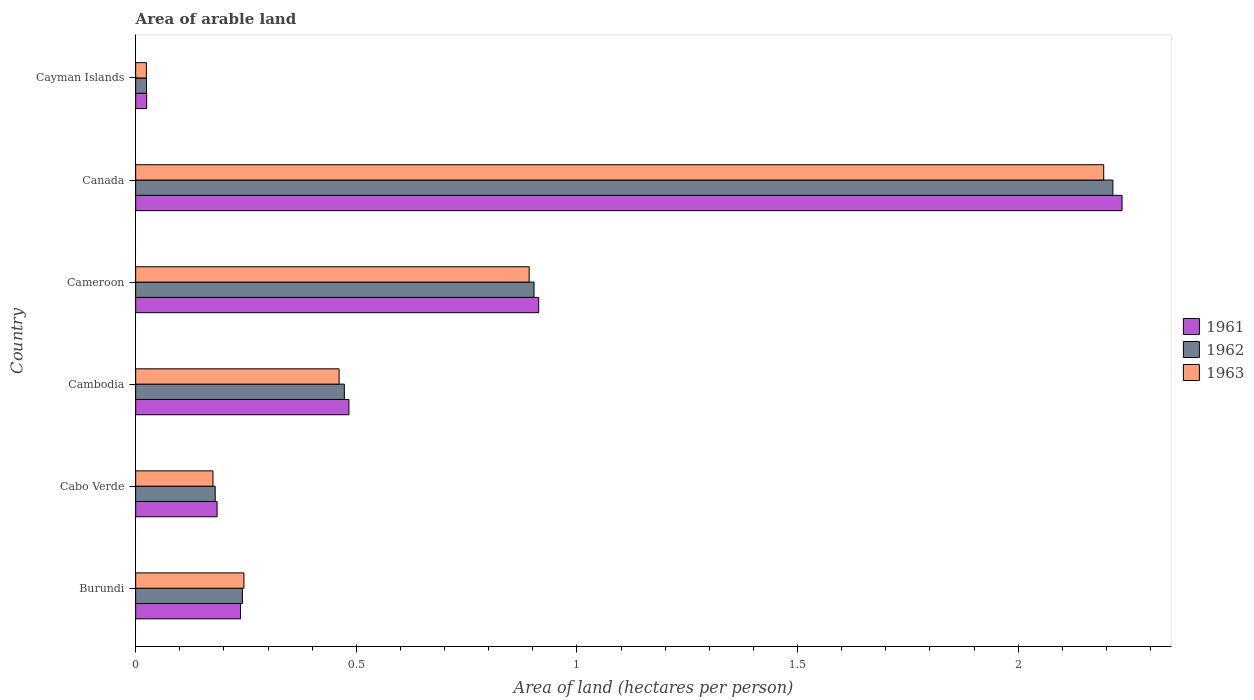How many groups of bars are there?
Your answer should be very brief. 6. Are the number of bars on each tick of the Y-axis equal?
Your answer should be compact. Yes. What is the total arable land in 1961 in Canada?
Ensure brevity in your answer.  2.24. Across all countries, what is the maximum total arable land in 1961?
Provide a short and direct response. 2.24. Across all countries, what is the minimum total arable land in 1962?
Your answer should be very brief. 0.02. In which country was the total arable land in 1963 maximum?
Ensure brevity in your answer.  Canada. In which country was the total arable land in 1963 minimum?
Give a very brief answer. Cayman Islands. What is the total total arable land in 1963 in the graph?
Your answer should be compact. 3.99. What is the difference between the total arable land in 1962 in Cameroon and that in Cayman Islands?
Offer a very short reply. 0.88. What is the difference between the total arable land in 1962 in Burundi and the total arable land in 1961 in Cabo Verde?
Your answer should be compact. 0.06. What is the average total arable land in 1962 per country?
Ensure brevity in your answer.  0.67. What is the difference between the total arable land in 1961 and total arable land in 1963 in Cambodia?
Your response must be concise. 0.02. In how many countries, is the total arable land in 1961 greater than 0.1 hectares per person?
Your answer should be very brief. 5. What is the ratio of the total arable land in 1962 in Cabo Verde to that in Canada?
Your answer should be very brief. 0.08. What is the difference between the highest and the second highest total arable land in 1962?
Provide a short and direct response. 1.31. What is the difference between the highest and the lowest total arable land in 1963?
Your response must be concise. 2.17. Is the sum of the total arable land in 1961 in Cabo Verde and Cambodia greater than the maximum total arable land in 1963 across all countries?
Provide a short and direct response. No. Is it the case that in every country, the sum of the total arable land in 1961 and total arable land in 1962 is greater than the total arable land in 1963?
Your response must be concise. Yes. Are all the bars in the graph horizontal?
Provide a succinct answer. Yes. Are the values on the major ticks of X-axis written in scientific E-notation?
Provide a short and direct response. No. Does the graph contain any zero values?
Provide a succinct answer. No. Does the graph contain grids?
Ensure brevity in your answer.  No. How many legend labels are there?
Your response must be concise. 3. What is the title of the graph?
Make the answer very short. Area of arable land. What is the label or title of the X-axis?
Offer a terse response. Area of land (hectares per person). What is the label or title of the Y-axis?
Provide a succinct answer. Country. What is the Area of land (hectares per person) in 1961 in Burundi?
Your response must be concise. 0.24. What is the Area of land (hectares per person) of 1962 in Burundi?
Keep it short and to the point. 0.24. What is the Area of land (hectares per person) in 1963 in Burundi?
Provide a short and direct response. 0.25. What is the Area of land (hectares per person) of 1961 in Cabo Verde?
Ensure brevity in your answer.  0.18. What is the Area of land (hectares per person) in 1962 in Cabo Verde?
Offer a terse response. 0.18. What is the Area of land (hectares per person) in 1963 in Cabo Verde?
Provide a short and direct response. 0.18. What is the Area of land (hectares per person) in 1961 in Cambodia?
Keep it short and to the point. 0.48. What is the Area of land (hectares per person) of 1962 in Cambodia?
Provide a short and direct response. 0.47. What is the Area of land (hectares per person) in 1963 in Cambodia?
Keep it short and to the point. 0.46. What is the Area of land (hectares per person) of 1961 in Cameroon?
Make the answer very short. 0.91. What is the Area of land (hectares per person) in 1962 in Cameroon?
Make the answer very short. 0.9. What is the Area of land (hectares per person) of 1963 in Cameroon?
Your answer should be compact. 0.89. What is the Area of land (hectares per person) of 1961 in Canada?
Ensure brevity in your answer.  2.24. What is the Area of land (hectares per person) of 1962 in Canada?
Provide a succinct answer. 2.21. What is the Area of land (hectares per person) in 1963 in Canada?
Offer a terse response. 2.19. What is the Area of land (hectares per person) in 1961 in Cayman Islands?
Provide a short and direct response. 0.02. What is the Area of land (hectares per person) of 1962 in Cayman Islands?
Offer a terse response. 0.02. What is the Area of land (hectares per person) of 1963 in Cayman Islands?
Provide a succinct answer. 0.02. Across all countries, what is the maximum Area of land (hectares per person) in 1961?
Your answer should be compact. 2.24. Across all countries, what is the maximum Area of land (hectares per person) of 1962?
Offer a very short reply. 2.21. Across all countries, what is the maximum Area of land (hectares per person) of 1963?
Give a very brief answer. 2.19. Across all countries, what is the minimum Area of land (hectares per person) of 1961?
Offer a very short reply. 0.02. Across all countries, what is the minimum Area of land (hectares per person) of 1962?
Your answer should be compact. 0.02. Across all countries, what is the minimum Area of land (hectares per person) in 1963?
Keep it short and to the point. 0.02. What is the total Area of land (hectares per person) of 1961 in the graph?
Your answer should be very brief. 4.08. What is the total Area of land (hectares per person) in 1962 in the graph?
Ensure brevity in your answer.  4.04. What is the total Area of land (hectares per person) in 1963 in the graph?
Your answer should be compact. 3.99. What is the difference between the Area of land (hectares per person) in 1961 in Burundi and that in Cabo Verde?
Your answer should be compact. 0.05. What is the difference between the Area of land (hectares per person) in 1962 in Burundi and that in Cabo Verde?
Keep it short and to the point. 0.06. What is the difference between the Area of land (hectares per person) in 1963 in Burundi and that in Cabo Verde?
Offer a terse response. 0.07. What is the difference between the Area of land (hectares per person) of 1961 in Burundi and that in Cambodia?
Provide a succinct answer. -0.25. What is the difference between the Area of land (hectares per person) of 1962 in Burundi and that in Cambodia?
Keep it short and to the point. -0.23. What is the difference between the Area of land (hectares per person) in 1963 in Burundi and that in Cambodia?
Ensure brevity in your answer.  -0.22. What is the difference between the Area of land (hectares per person) in 1961 in Burundi and that in Cameroon?
Ensure brevity in your answer.  -0.68. What is the difference between the Area of land (hectares per person) of 1962 in Burundi and that in Cameroon?
Offer a terse response. -0.66. What is the difference between the Area of land (hectares per person) of 1963 in Burundi and that in Cameroon?
Keep it short and to the point. -0.65. What is the difference between the Area of land (hectares per person) in 1961 in Burundi and that in Canada?
Ensure brevity in your answer.  -2. What is the difference between the Area of land (hectares per person) of 1962 in Burundi and that in Canada?
Your response must be concise. -1.97. What is the difference between the Area of land (hectares per person) in 1963 in Burundi and that in Canada?
Your response must be concise. -1.95. What is the difference between the Area of land (hectares per person) of 1961 in Burundi and that in Cayman Islands?
Provide a short and direct response. 0.21. What is the difference between the Area of land (hectares per person) of 1962 in Burundi and that in Cayman Islands?
Ensure brevity in your answer.  0.22. What is the difference between the Area of land (hectares per person) of 1963 in Burundi and that in Cayman Islands?
Provide a short and direct response. 0.22. What is the difference between the Area of land (hectares per person) in 1961 in Cabo Verde and that in Cambodia?
Keep it short and to the point. -0.3. What is the difference between the Area of land (hectares per person) in 1962 in Cabo Verde and that in Cambodia?
Ensure brevity in your answer.  -0.29. What is the difference between the Area of land (hectares per person) in 1963 in Cabo Verde and that in Cambodia?
Make the answer very short. -0.29. What is the difference between the Area of land (hectares per person) of 1961 in Cabo Verde and that in Cameroon?
Offer a very short reply. -0.73. What is the difference between the Area of land (hectares per person) in 1962 in Cabo Verde and that in Cameroon?
Offer a very short reply. -0.72. What is the difference between the Area of land (hectares per person) in 1963 in Cabo Verde and that in Cameroon?
Offer a terse response. -0.72. What is the difference between the Area of land (hectares per person) of 1961 in Cabo Verde and that in Canada?
Offer a terse response. -2.05. What is the difference between the Area of land (hectares per person) in 1962 in Cabo Verde and that in Canada?
Keep it short and to the point. -2.03. What is the difference between the Area of land (hectares per person) in 1963 in Cabo Verde and that in Canada?
Your answer should be very brief. -2.02. What is the difference between the Area of land (hectares per person) in 1961 in Cabo Verde and that in Cayman Islands?
Your answer should be very brief. 0.16. What is the difference between the Area of land (hectares per person) in 1962 in Cabo Verde and that in Cayman Islands?
Your response must be concise. 0.16. What is the difference between the Area of land (hectares per person) of 1963 in Cabo Verde and that in Cayman Islands?
Ensure brevity in your answer.  0.15. What is the difference between the Area of land (hectares per person) of 1961 in Cambodia and that in Cameroon?
Offer a very short reply. -0.43. What is the difference between the Area of land (hectares per person) in 1962 in Cambodia and that in Cameroon?
Give a very brief answer. -0.43. What is the difference between the Area of land (hectares per person) of 1963 in Cambodia and that in Cameroon?
Your answer should be compact. -0.43. What is the difference between the Area of land (hectares per person) of 1961 in Cambodia and that in Canada?
Ensure brevity in your answer.  -1.75. What is the difference between the Area of land (hectares per person) of 1962 in Cambodia and that in Canada?
Give a very brief answer. -1.74. What is the difference between the Area of land (hectares per person) in 1963 in Cambodia and that in Canada?
Offer a very short reply. -1.73. What is the difference between the Area of land (hectares per person) in 1961 in Cambodia and that in Cayman Islands?
Your response must be concise. 0.46. What is the difference between the Area of land (hectares per person) of 1962 in Cambodia and that in Cayman Islands?
Make the answer very short. 0.45. What is the difference between the Area of land (hectares per person) of 1963 in Cambodia and that in Cayman Islands?
Offer a very short reply. 0.44. What is the difference between the Area of land (hectares per person) in 1961 in Cameroon and that in Canada?
Provide a short and direct response. -1.32. What is the difference between the Area of land (hectares per person) of 1962 in Cameroon and that in Canada?
Your answer should be compact. -1.31. What is the difference between the Area of land (hectares per person) of 1963 in Cameroon and that in Canada?
Ensure brevity in your answer.  -1.3. What is the difference between the Area of land (hectares per person) in 1961 in Cameroon and that in Cayman Islands?
Your answer should be compact. 0.89. What is the difference between the Area of land (hectares per person) in 1962 in Cameroon and that in Cayman Islands?
Your response must be concise. 0.88. What is the difference between the Area of land (hectares per person) in 1963 in Cameroon and that in Cayman Islands?
Provide a succinct answer. 0.87. What is the difference between the Area of land (hectares per person) in 1961 in Canada and that in Cayman Islands?
Your response must be concise. 2.21. What is the difference between the Area of land (hectares per person) in 1962 in Canada and that in Cayman Islands?
Offer a terse response. 2.19. What is the difference between the Area of land (hectares per person) of 1963 in Canada and that in Cayman Islands?
Provide a succinct answer. 2.17. What is the difference between the Area of land (hectares per person) of 1961 in Burundi and the Area of land (hectares per person) of 1962 in Cabo Verde?
Give a very brief answer. 0.06. What is the difference between the Area of land (hectares per person) in 1961 in Burundi and the Area of land (hectares per person) in 1963 in Cabo Verde?
Your response must be concise. 0.06. What is the difference between the Area of land (hectares per person) of 1962 in Burundi and the Area of land (hectares per person) of 1963 in Cabo Verde?
Offer a very short reply. 0.07. What is the difference between the Area of land (hectares per person) in 1961 in Burundi and the Area of land (hectares per person) in 1962 in Cambodia?
Offer a terse response. -0.24. What is the difference between the Area of land (hectares per person) in 1961 in Burundi and the Area of land (hectares per person) in 1963 in Cambodia?
Your answer should be compact. -0.22. What is the difference between the Area of land (hectares per person) of 1962 in Burundi and the Area of land (hectares per person) of 1963 in Cambodia?
Offer a very short reply. -0.22. What is the difference between the Area of land (hectares per person) in 1961 in Burundi and the Area of land (hectares per person) in 1962 in Cameroon?
Offer a terse response. -0.67. What is the difference between the Area of land (hectares per person) in 1961 in Burundi and the Area of land (hectares per person) in 1963 in Cameroon?
Offer a terse response. -0.65. What is the difference between the Area of land (hectares per person) in 1962 in Burundi and the Area of land (hectares per person) in 1963 in Cameroon?
Make the answer very short. -0.65. What is the difference between the Area of land (hectares per person) of 1961 in Burundi and the Area of land (hectares per person) of 1962 in Canada?
Keep it short and to the point. -1.98. What is the difference between the Area of land (hectares per person) in 1961 in Burundi and the Area of land (hectares per person) in 1963 in Canada?
Keep it short and to the point. -1.96. What is the difference between the Area of land (hectares per person) of 1962 in Burundi and the Area of land (hectares per person) of 1963 in Canada?
Make the answer very short. -1.95. What is the difference between the Area of land (hectares per person) of 1961 in Burundi and the Area of land (hectares per person) of 1962 in Cayman Islands?
Offer a terse response. 0.21. What is the difference between the Area of land (hectares per person) in 1961 in Burundi and the Area of land (hectares per person) in 1963 in Cayman Islands?
Give a very brief answer. 0.21. What is the difference between the Area of land (hectares per person) of 1962 in Burundi and the Area of land (hectares per person) of 1963 in Cayman Islands?
Provide a succinct answer. 0.22. What is the difference between the Area of land (hectares per person) in 1961 in Cabo Verde and the Area of land (hectares per person) in 1962 in Cambodia?
Your answer should be very brief. -0.29. What is the difference between the Area of land (hectares per person) of 1961 in Cabo Verde and the Area of land (hectares per person) of 1963 in Cambodia?
Provide a succinct answer. -0.28. What is the difference between the Area of land (hectares per person) of 1962 in Cabo Verde and the Area of land (hectares per person) of 1963 in Cambodia?
Give a very brief answer. -0.28. What is the difference between the Area of land (hectares per person) of 1961 in Cabo Verde and the Area of land (hectares per person) of 1962 in Cameroon?
Keep it short and to the point. -0.72. What is the difference between the Area of land (hectares per person) in 1961 in Cabo Verde and the Area of land (hectares per person) in 1963 in Cameroon?
Your response must be concise. -0.71. What is the difference between the Area of land (hectares per person) in 1962 in Cabo Verde and the Area of land (hectares per person) in 1963 in Cameroon?
Your response must be concise. -0.71. What is the difference between the Area of land (hectares per person) of 1961 in Cabo Verde and the Area of land (hectares per person) of 1962 in Canada?
Offer a terse response. -2.03. What is the difference between the Area of land (hectares per person) in 1961 in Cabo Verde and the Area of land (hectares per person) in 1963 in Canada?
Offer a very short reply. -2.01. What is the difference between the Area of land (hectares per person) in 1962 in Cabo Verde and the Area of land (hectares per person) in 1963 in Canada?
Offer a terse response. -2.01. What is the difference between the Area of land (hectares per person) of 1961 in Cabo Verde and the Area of land (hectares per person) of 1962 in Cayman Islands?
Make the answer very short. 0.16. What is the difference between the Area of land (hectares per person) in 1961 in Cabo Verde and the Area of land (hectares per person) in 1963 in Cayman Islands?
Provide a succinct answer. 0.16. What is the difference between the Area of land (hectares per person) of 1962 in Cabo Verde and the Area of land (hectares per person) of 1963 in Cayman Islands?
Your answer should be very brief. 0.16. What is the difference between the Area of land (hectares per person) in 1961 in Cambodia and the Area of land (hectares per person) in 1962 in Cameroon?
Offer a terse response. -0.42. What is the difference between the Area of land (hectares per person) in 1961 in Cambodia and the Area of land (hectares per person) in 1963 in Cameroon?
Keep it short and to the point. -0.41. What is the difference between the Area of land (hectares per person) of 1962 in Cambodia and the Area of land (hectares per person) of 1963 in Cameroon?
Your answer should be compact. -0.42. What is the difference between the Area of land (hectares per person) of 1961 in Cambodia and the Area of land (hectares per person) of 1962 in Canada?
Keep it short and to the point. -1.73. What is the difference between the Area of land (hectares per person) of 1961 in Cambodia and the Area of land (hectares per person) of 1963 in Canada?
Offer a terse response. -1.71. What is the difference between the Area of land (hectares per person) in 1962 in Cambodia and the Area of land (hectares per person) in 1963 in Canada?
Keep it short and to the point. -1.72. What is the difference between the Area of land (hectares per person) in 1961 in Cambodia and the Area of land (hectares per person) in 1962 in Cayman Islands?
Give a very brief answer. 0.46. What is the difference between the Area of land (hectares per person) of 1961 in Cambodia and the Area of land (hectares per person) of 1963 in Cayman Islands?
Offer a very short reply. 0.46. What is the difference between the Area of land (hectares per person) of 1962 in Cambodia and the Area of land (hectares per person) of 1963 in Cayman Islands?
Your response must be concise. 0.45. What is the difference between the Area of land (hectares per person) in 1961 in Cameroon and the Area of land (hectares per person) in 1962 in Canada?
Ensure brevity in your answer.  -1.3. What is the difference between the Area of land (hectares per person) of 1961 in Cameroon and the Area of land (hectares per person) of 1963 in Canada?
Offer a terse response. -1.28. What is the difference between the Area of land (hectares per person) of 1962 in Cameroon and the Area of land (hectares per person) of 1963 in Canada?
Keep it short and to the point. -1.29. What is the difference between the Area of land (hectares per person) in 1961 in Cameroon and the Area of land (hectares per person) in 1962 in Cayman Islands?
Offer a very short reply. 0.89. What is the difference between the Area of land (hectares per person) of 1961 in Cameroon and the Area of land (hectares per person) of 1963 in Cayman Islands?
Make the answer very short. 0.89. What is the difference between the Area of land (hectares per person) in 1962 in Cameroon and the Area of land (hectares per person) in 1963 in Cayman Islands?
Keep it short and to the point. 0.88. What is the difference between the Area of land (hectares per person) of 1961 in Canada and the Area of land (hectares per person) of 1962 in Cayman Islands?
Offer a very short reply. 2.21. What is the difference between the Area of land (hectares per person) of 1961 in Canada and the Area of land (hectares per person) of 1963 in Cayman Islands?
Your response must be concise. 2.21. What is the difference between the Area of land (hectares per person) in 1962 in Canada and the Area of land (hectares per person) in 1963 in Cayman Islands?
Give a very brief answer. 2.19. What is the average Area of land (hectares per person) of 1961 per country?
Make the answer very short. 0.68. What is the average Area of land (hectares per person) of 1962 per country?
Your response must be concise. 0.67. What is the average Area of land (hectares per person) of 1963 per country?
Provide a succinct answer. 0.67. What is the difference between the Area of land (hectares per person) in 1961 and Area of land (hectares per person) in 1962 in Burundi?
Your answer should be compact. -0. What is the difference between the Area of land (hectares per person) in 1961 and Area of land (hectares per person) in 1963 in Burundi?
Ensure brevity in your answer.  -0.01. What is the difference between the Area of land (hectares per person) of 1962 and Area of land (hectares per person) of 1963 in Burundi?
Your response must be concise. -0. What is the difference between the Area of land (hectares per person) in 1961 and Area of land (hectares per person) in 1962 in Cabo Verde?
Your answer should be very brief. 0. What is the difference between the Area of land (hectares per person) of 1961 and Area of land (hectares per person) of 1963 in Cabo Verde?
Your answer should be compact. 0.01. What is the difference between the Area of land (hectares per person) of 1962 and Area of land (hectares per person) of 1963 in Cabo Verde?
Your response must be concise. 0.01. What is the difference between the Area of land (hectares per person) of 1961 and Area of land (hectares per person) of 1962 in Cambodia?
Your answer should be very brief. 0.01. What is the difference between the Area of land (hectares per person) of 1961 and Area of land (hectares per person) of 1963 in Cambodia?
Your answer should be very brief. 0.02. What is the difference between the Area of land (hectares per person) in 1962 and Area of land (hectares per person) in 1963 in Cambodia?
Make the answer very short. 0.01. What is the difference between the Area of land (hectares per person) in 1961 and Area of land (hectares per person) in 1962 in Cameroon?
Your answer should be compact. 0.01. What is the difference between the Area of land (hectares per person) in 1961 and Area of land (hectares per person) in 1963 in Cameroon?
Keep it short and to the point. 0.02. What is the difference between the Area of land (hectares per person) of 1962 and Area of land (hectares per person) of 1963 in Cameroon?
Offer a very short reply. 0.01. What is the difference between the Area of land (hectares per person) of 1961 and Area of land (hectares per person) of 1962 in Canada?
Keep it short and to the point. 0.02. What is the difference between the Area of land (hectares per person) of 1961 and Area of land (hectares per person) of 1963 in Canada?
Provide a short and direct response. 0.04. What is the difference between the Area of land (hectares per person) in 1962 and Area of land (hectares per person) in 1963 in Canada?
Ensure brevity in your answer.  0.02. What is the difference between the Area of land (hectares per person) in 1961 and Area of land (hectares per person) in 1963 in Cayman Islands?
Your answer should be very brief. 0. What is the difference between the Area of land (hectares per person) in 1962 and Area of land (hectares per person) in 1963 in Cayman Islands?
Provide a succinct answer. 0. What is the ratio of the Area of land (hectares per person) in 1961 in Burundi to that in Cabo Verde?
Provide a short and direct response. 1.29. What is the ratio of the Area of land (hectares per person) of 1962 in Burundi to that in Cabo Verde?
Your answer should be very brief. 1.34. What is the ratio of the Area of land (hectares per person) of 1963 in Burundi to that in Cabo Verde?
Make the answer very short. 1.4. What is the ratio of the Area of land (hectares per person) of 1961 in Burundi to that in Cambodia?
Give a very brief answer. 0.49. What is the ratio of the Area of land (hectares per person) in 1962 in Burundi to that in Cambodia?
Ensure brevity in your answer.  0.51. What is the ratio of the Area of land (hectares per person) in 1963 in Burundi to that in Cambodia?
Provide a succinct answer. 0.53. What is the ratio of the Area of land (hectares per person) of 1961 in Burundi to that in Cameroon?
Your response must be concise. 0.26. What is the ratio of the Area of land (hectares per person) of 1962 in Burundi to that in Cameroon?
Offer a terse response. 0.27. What is the ratio of the Area of land (hectares per person) of 1963 in Burundi to that in Cameroon?
Offer a terse response. 0.28. What is the ratio of the Area of land (hectares per person) of 1961 in Burundi to that in Canada?
Your response must be concise. 0.11. What is the ratio of the Area of land (hectares per person) of 1962 in Burundi to that in Canada?
Ensure brevity in your answer.  0.11. What is the ratio of the Area of land (hectares per person) in 1963 in Burundi to that in Canada?
Offer a very short reply. 0.11. What is the ratio of the Area of land (hectares per person) in 1961 in Burundi to that in Cayman Islands?
Ensure brevity in your answer.  9.54. What is the ratio of the Area of land (hectares per person) in 1962 in Burundi to that in Cayman Islands?
Ensure brevity in your answer.  9.85. What is the ratio of the Area of land (hectares per person) in 1963 in Burundi to that in Cayman Islands?
Give a very brief answer. 10.09. What is the ratio of the Area of land (hectares per person) in 1961 in Cabo Verde to that in Cambodia?
Ensure brevity in your answer.  0.38. What is the ratio of the Area of land (hectares per person) in 1962 in Cabo Verde to that in Cambodia?
Give a very brief answer. 0.38. What is the ratio of the Area of land (hectares per person) of 1963 in Cabo Verde to that in Cambodia?
Your response must be concise. 0.38. What is the ratio of the Area of land (hectares per person) of 1961 in Cabo Verde to that in Cameroon?
Your answer should be very brief. 0.2. What is the ratio of the Area of land (hectares per person) in 1962 in Cabo Verde to that in Cameroon?
Provide a succinct answer. 0.2. What is the ratio of the Area of land (hectares per person) in 1963 in Cabo Verde to that in Cameroon?
Offer a terse response. 0.2. What is the ratio of the Area of land (hectares per person) of 1961 in Cabo Verde to that in Canada?
Give a very brief answer. 0.08. What is the ratio of the Area of land (hectares per person) in 1962 in Cabo Verde to that in Canada?
Provide a succinct answer. 0.08. What is the ratio of the Area of land (hectares per person) of 1963 in Cabo Verde to that in Canada?
Ensure brevity in your answer.  0.08. What is the ratio of the Area of land (hectares per person) of 1961 in Cabo Verde to that in Cayman Islands?
Ensure brevity in your answer.  7.4. What is the ratio of the Area of land (hectares per person) in 1962 in Cabo Verde to that in Cayman Islands?
Your answer should be very brief. 7.34. What is the ratio of the Area of land (hectares per person) of 1963 in Cabo Verde to that in Cayman Islands?
Keep it short and to the point. 7.21. What is the ratio of the Area of land (hectares per person) of 1961 in Cambodia to that in Cameroon?
Your answer should be very brief. 0.53. What is the ratio of the Area of land (hectares per person) of 1962 in Cambodia to that in Cameroon?
Make the answer very short. 0.52. What is the ratio of the Area of land (hectares per person) of 1963 in Cambodia to that in Cameroon?
Your answer should be compact. 0.52. What is the ratio of the Area of land (hectares per person) in 1961 in Cambodia to that in Canada?
Ensure brevity in your answer.  0.22. What is the ratio of the Area of land (hectares per person) in 1962 in Cambodia to that in Canada?
Provide a short and direct response. 0.21. What is the ratio of the Area of land (hectares per person) in 1963 in Cambodia to that in Canada?
Offer a very short reply. 0.21. What is the ratio of the Area of land (hectares per person) in 1961 in Cambodia to that in Cayman Islands?
Offer a terse response. 19.39. What is the ratio of the Area of land (hectares per person) of 1962 in Cambodia to that in Cayman Islands?
Keep it short and to the point. 19.25. What is the ratio of the Area of land (hectares per person) of 1963 in Cambodia to that in Cayman Islands?
Offer a terse response. 18.97. What is the ratio of the Area of land (hectares per person) in 1961 in Cameroon to that in Canada?
Make the answer very short. 0.41. What is the ratio of the Area of land (hectares per person) of 1962 in Cameroon to that in Canada?
Your response must be concise. 0.41. What is the ratio of the Area of land (hectares per person) in 1963 in Cameroon to that in Canada?
Your answer should be compact. 0.41. What is the ratio of the Area of land (hectares per person) of 1961 in Cameroon to that in Cayman Islands?
Keep it short and to the point. 36.65. What is the ratio of the Area of land (hectares per person) in 1962 in Cameroon to that in Cayman Islands?
Your response must be concise. 36.75. What is the ratio of the Area of land (hectares per person) of 1963 in Cameroon to that in Cayman Islands?
Offer a very short reply. 36.69. What is the ratio of the Area of land (hectares per person) in 1961 in Canada to that in Cayman Islands?
Make the answer very short. 89.71. What is the ratio of the Area of land (hectares per person) in 1962 in Canada to that in Cayman Islands?
Provide a short and direct response. 90.16. What is the ratio of the Area of land (hectares per person) in 1963 in Canada to that in Cayman Islands?
Provide a short and direct response. 90.25. What is the difference between the highest and the second highest Area of land (hectares per person) of 1961?
Your response must be concise. 1.32. What is the difference between the highest and the second highest Area of land (hectares per person) of 1962?
Ensure brevity in your answer.  1.31. What is the difference between the highest and the second highest Area of land (hectares per person) in 1963?
Offer a terse response. 1.3. What is the difference between the highest and the lowest Area of land (hectares per person) in 1961?
Ensure brevity in your answer.  2.21. What is the difference between the highest and the lowest Area of land (hectares per person) in 1962?
Your response must be concise. 2.19. What is the difference between the highest and the lowest Area of land (hectares per person) of 1963?
Keep it short and to the point. 2.17. 